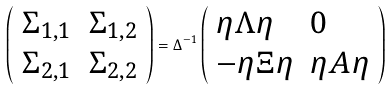Convert formula to latex. <formula><loc_0><loc_0><loc_500><loc_500>\left ( \begin{array} { l l } \Sigma _ { 1 , 1 } & \Sigma _ { 1 , 2 } \\ \Sigma _ { 2 , 1 } & \Sigma _ { 2 , 2 } \end{array} \right ) = \Delta ^ { - 1 } \left ( \begin{array} { l l } \eta \Lambda \eta & 0 \\ - \eta \Xi \eta & \eta A \eta \end{array} \right )</formula> 